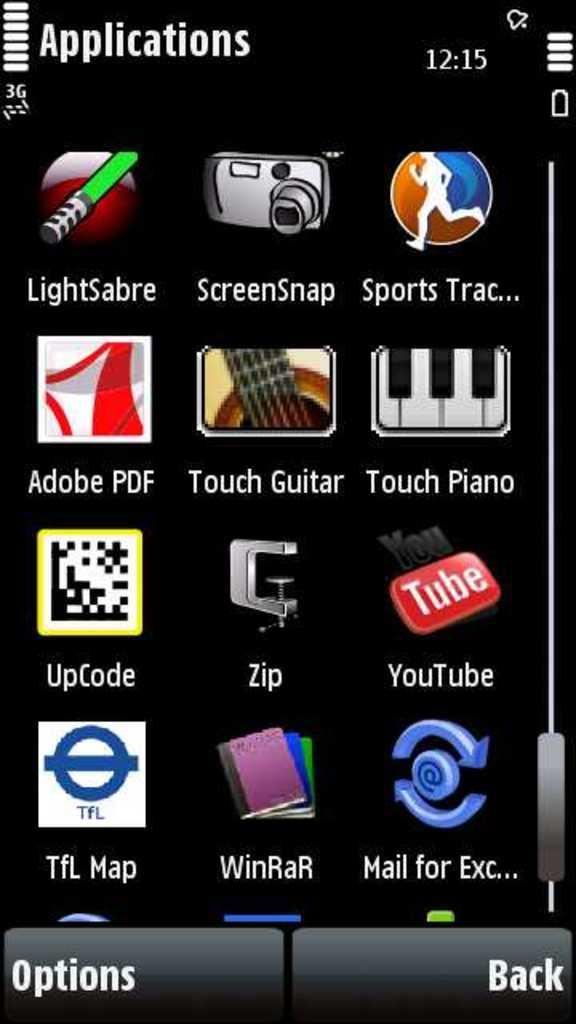What is the name of the app with the camera icon?
Keep it short and to the point. Screensnap. What is the name of the app with a piano icon?
Keep it short and to the point. Touch piano. 